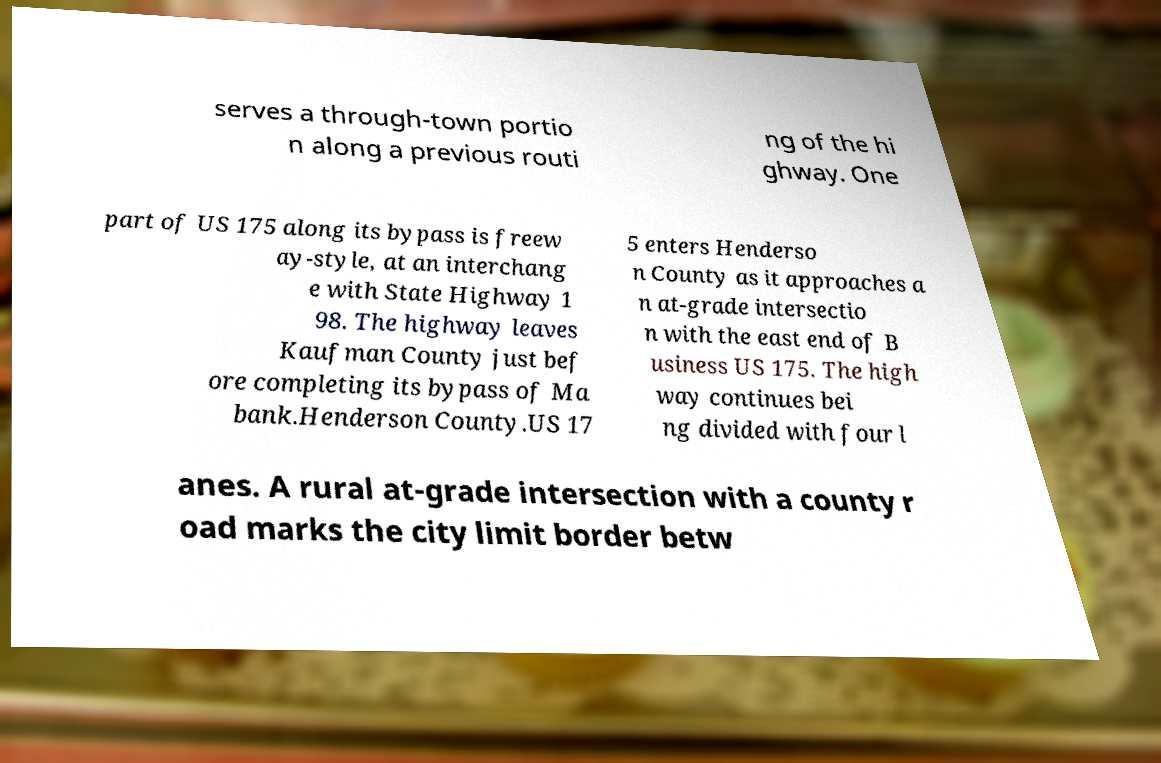For documentation purposes, I need the text within this image transcribed. Could you provide that? serves a through-town portio n along a previous routi ng of the hi ghway. One part of US 175 along its bypass is freew ay-style, at an interchang e with State Highway 1 98. The highway leaves Kaufman County just bef ore completing its bypass of Ma bank.Henderson County.US 17 5 enters Henderso n County as it approaches a n at-grade intersectio n with the east end of B usiness US 175. The high way continues bei ng divided with four l anes. A rural at-grade intersection with a county r oad marks the city limit border betw 